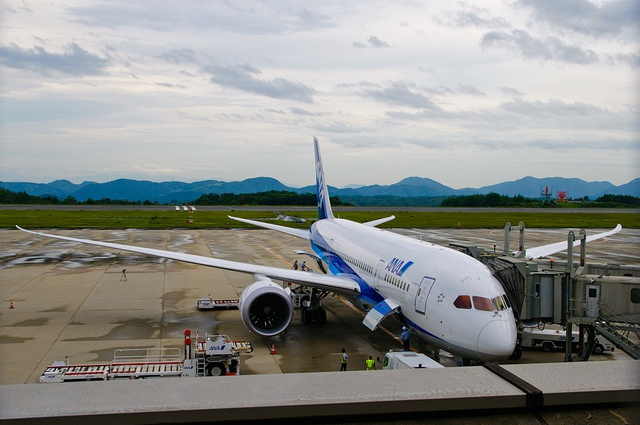Describe the objects in this image and their specific colors. I can see airplane in lightgray, darkgray, black, and gray tones, truck in lightgray, darkgray, gray, black, and maroon tones, truck in lightgray, darkgray, gray, and black tones, people in lightgray, black, darkgreen, and gray tones, and people in lightgray, black, navy, darkblue, and blue tones in this image. 